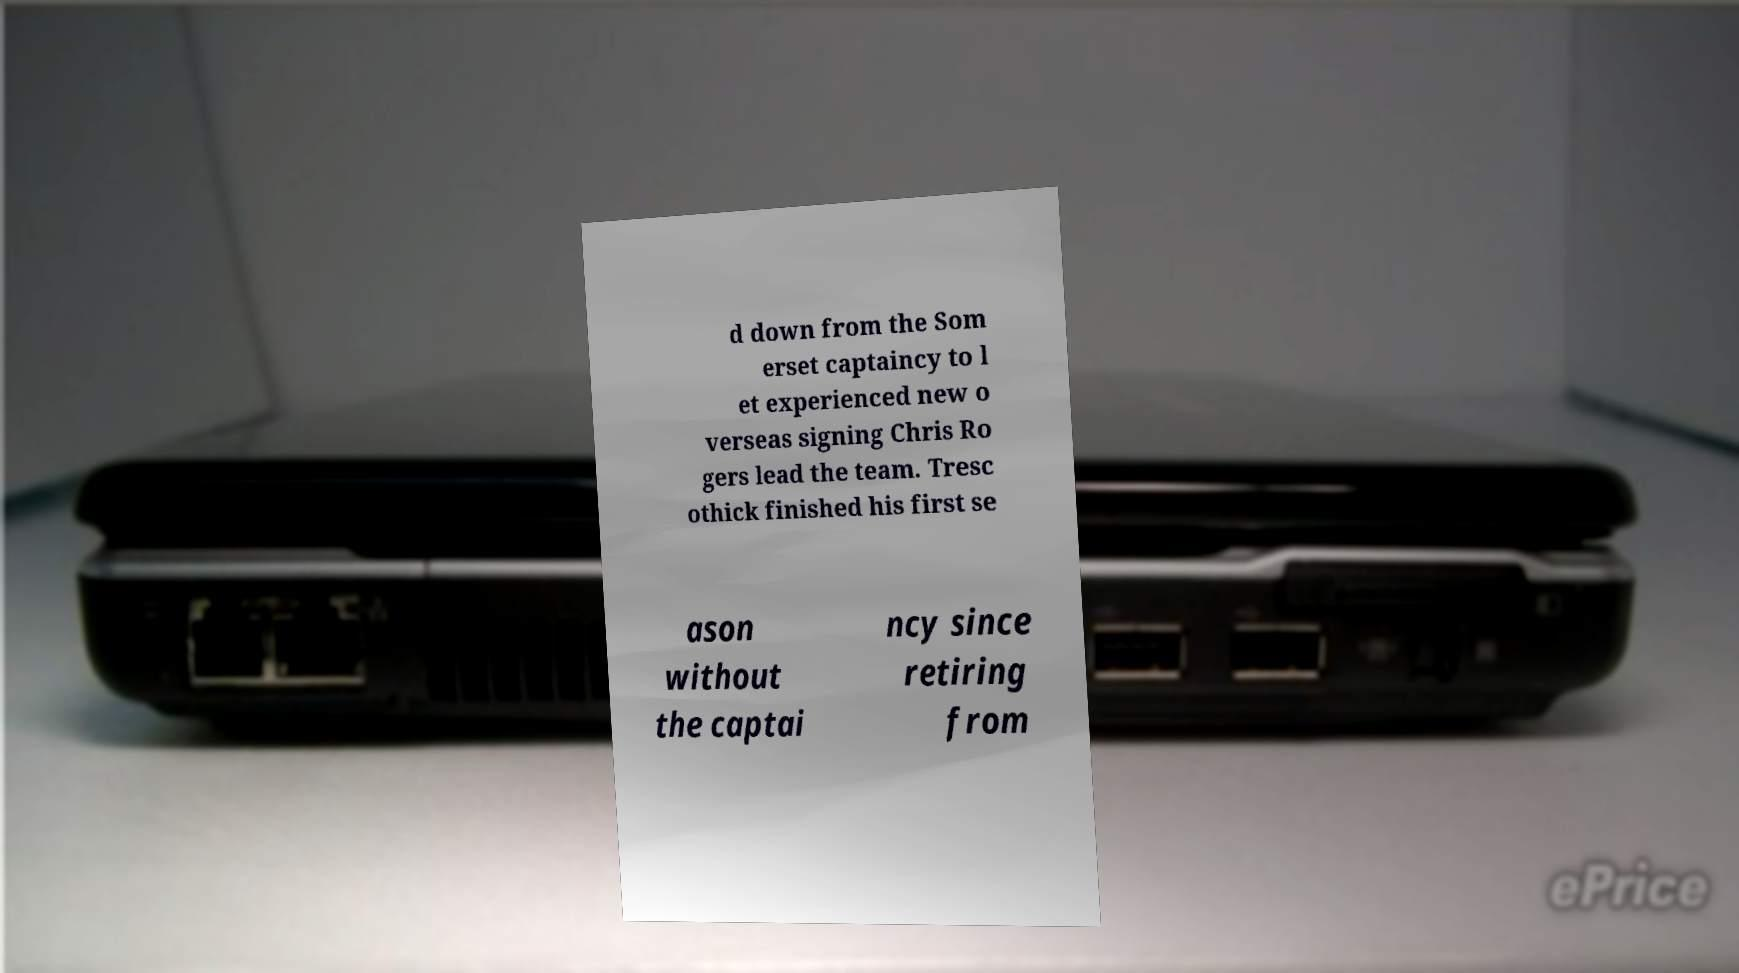I need the written content from this picture converted into text. Can you do that? d down from the Som erset captaincy to l et experienced new o verseas signing Chris Ro gers lead the team. Tresc othick finished his first se ason without the captai ncy since retiring from 